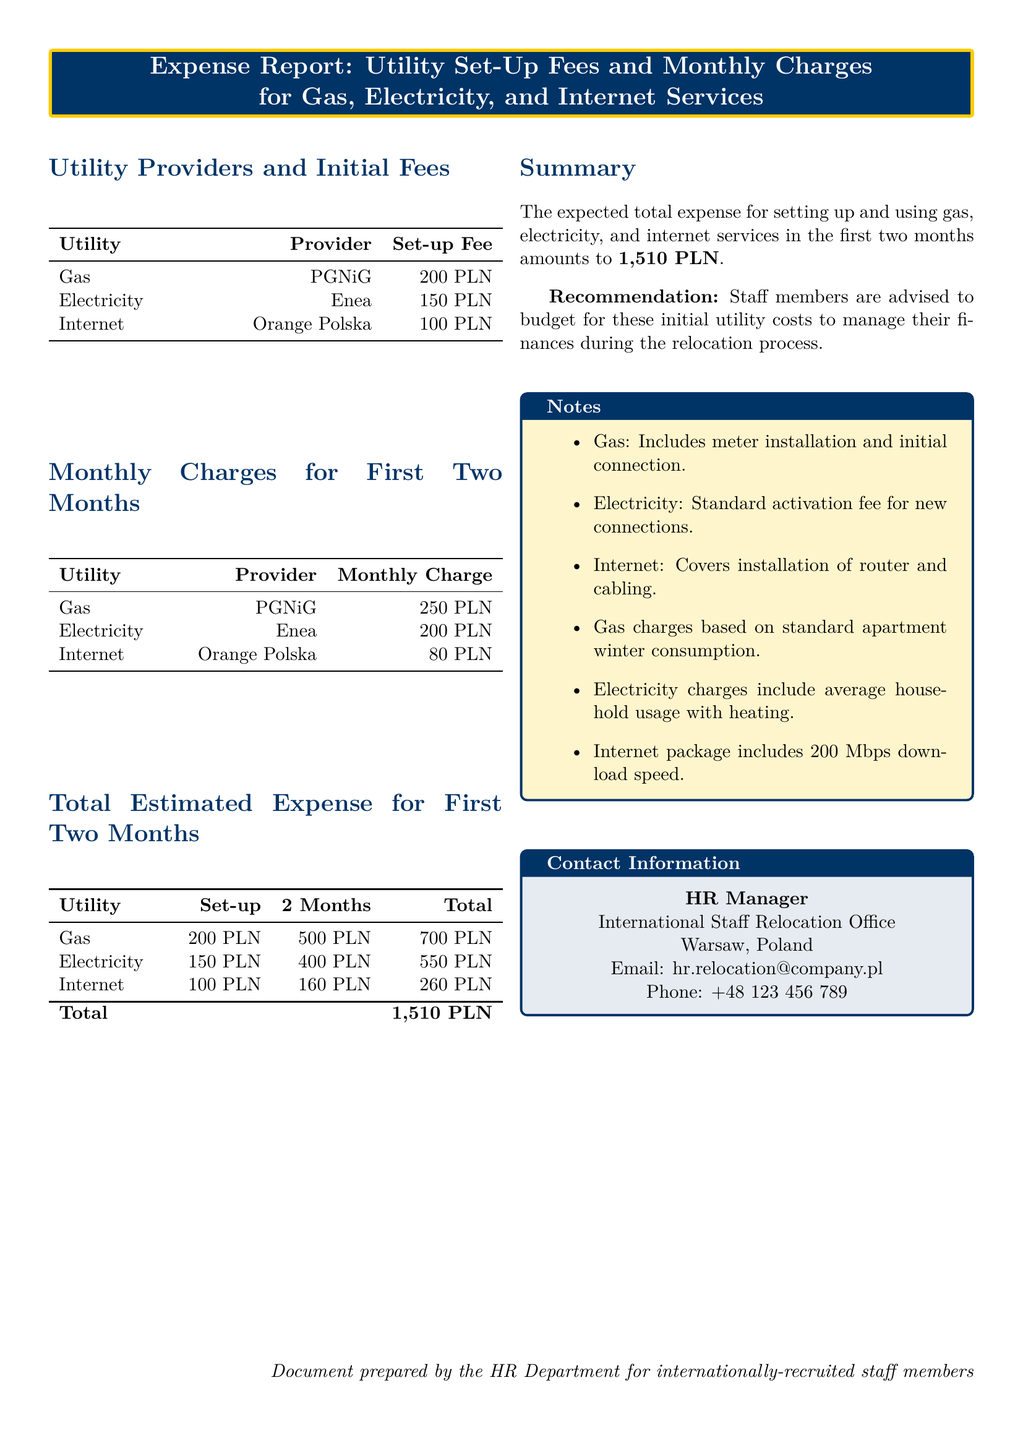What is the total estimated expense for the first two months? The total estimated expense is provided in the summary section of the document.
Answer: 1,510 PLN What is the set-up fee for electricity? The set-up fee for electricity is listed in the utility providers and initial fees table.
Answer: 150 PLN Who is the provider of the internet service? The provider of the internet service is mentioned in the utility providers table.
Answer: Orange Polska What is the monthly charge for gas? The monthly charge for gas is displayed in the monthly charges for the first two months table.
Answer: 250 PLN What does the total charge for internet include? The notes section mentions the specifics of the internet package.
Answer: Installation of router and cabling How much will the total charge for gas and electricity be? The total charge for gas is 700 PLN, and for electricity, it is 550 PLN, which requires summation.
Answer: 1,250 PLN What is the expected internet monthly charge for the first two months? The document outlines the expected internet monthly charge under the monthly charges section.
Answer: 80 PLN What type of document is this? The document title clearly indicates its purpose.
Answer: Expense Report How many types of utilities are listed in the document? The document mentions three utilities: gas, electricity, and internet.
Answer: Three 